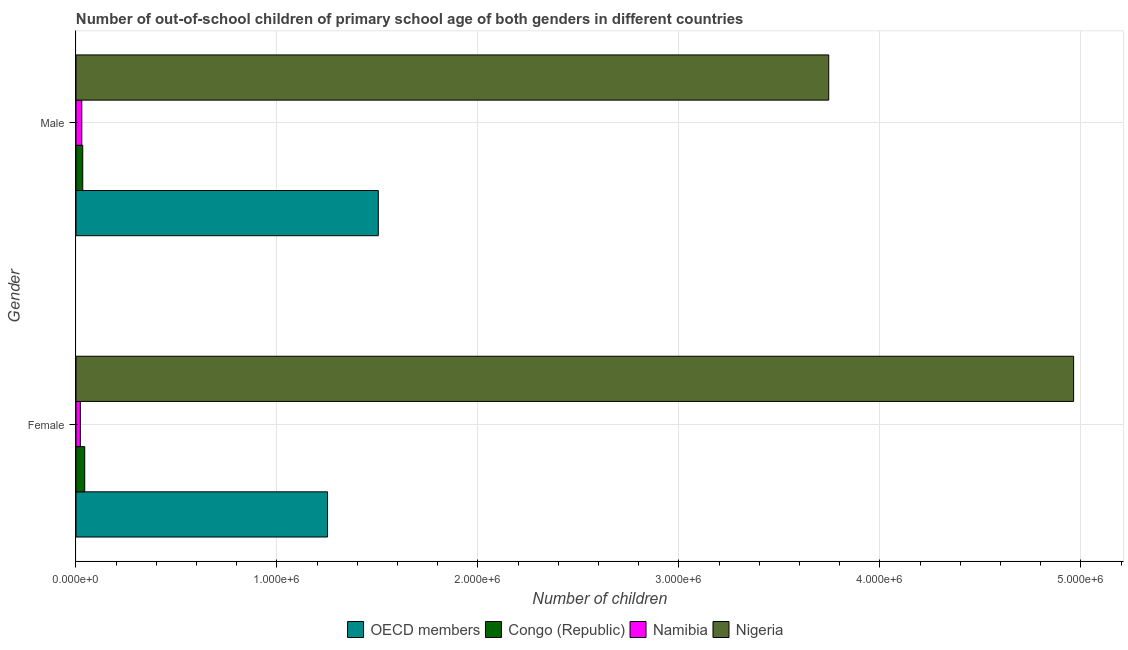Are the number of bars per tick equal to the number of legend labels?
Offer a very short reply. Yes. How many bars are there on the 2nd tick from the top?
Ensure brevity in your answer.  4. How many bars are there on the 2nd tick from the bottom?
Give a very brief answer. 4. What is the number of male out-of-school students in Namibia?
Ensure brevity in your answer.  2.89e+04. Across all countries, what is the maximum number of male out-of-school students?
Your response must be concise. 3.75e+06. Across all countries, what is the minimum number of male out-of-school students?
Provide a short and direct response. 2.89e+04. In which country was the number of female out-of-school students maximum?
Offer a very short reply. Nigeria. In which country was the number of male out-of-school students minimum?
Your response must be concise. Namibia. What is the total number of male out-of-school students in the graph?
Ensure brevity in your answer.  5.31e+06. What is the difference between the number of male out-of-school students in OECD members and that in Namibia?
Your response must be concise. 1.48e+06. What is the difference between the number of female out-of-school students in Nigeria and the number of male out-of-school students in Congo (Republic)?
Provide a succinct answer. 4.93e+06. What is the average number of female out-of-school students per country?
Your response must be concise. 1.57e+06. What is the difference between the number of male out-of-school students and number of female out-of-school students in Congo (Republic)?
Make the answer very short. -9825. What is the ratio of the number of male out-of-school students in Congo (Republic) to that in OECD members?
Your answer should be very brief. 0.02. Is the number of male out-of-school students in Congo (Republic) less than that in OECD members?
Your response must be concise. Yes. What does the 3rd bar from the top in Male represents?
Offer a terse response. Congo (Republic). What does the 3rd bar from the bottom in Female represents?
Your response must be concise. Namibia. How many bars are there?
Provide a short and direct response. 8. How many countries are there in the graph?
Offer a terse response. 4. What is the difference between two consecutive major ticks on the X-axis?
Your response must be concise. 1.00e+06. How are the legend labels stacked?
Your answer should be very brief. Horizontal. What is the title of the graph?
Your response must be concise. Number of out-of-school children of primary school age of both genders in different countries. What is the label or title of the X-axis?
Offer a very short reply. Number of children. What is the label or title of the Y-axis?
Ensure brevity in your answer.  Gender. What is the Number of children of OECD members in Female?
Your answer should be compact. 1.25e+06. What is the Number of children of Congo (Republic) in Female?
Make the answer very short. 4.35e+04. What is the Number of children of Namibia in Female?
Your response must be concise. 2.17e+04. What is the Number of children in Nigeria in Female?
Give a very brief answer. 4.96e+06. What is the Number of children of OECD members in Male?
Provide a succinct answer. 1.50e+06. What is the Number of children in Congo (Republic) in Male?
Your response must be concise. 3.37e+04. What is the Number of children of Namibia in Male?
Provide a succinct answer. 2.89e+04. What is the Number of children of Nigeria in Male?
Give a very brief answer. 3.75e+06. Across all Gender, what is the maximum Number of children of OECD members?
Provide a short and direct response. 1.50e+06. Across all Gender, what is the maximum Number of children in Congo (Republic)?
Your response must be concise. 4.35e+04. Across all Gender, what is the maximum Number of children in Namibia?
Your answer should be compact. 2.89e+04. Across all Gender, what is the maximum Number of children in Nigeria?
Ensure brevity in your answer.  4.96e+06. Across all Gender, what is the minimum Number of children of OECD members?
Provide a short and direct response. 1.25e+06. Across all Gender, what is the minimum Number of children in Congo (Republic)?
Keep it short and to the point. 3.37e+04. Across all Gender, what is the minimum Number of children of Namibia?
Your answer should be compact. 2.17e+04. Across all Gender, what is the minimum Number of children of Nigeria?
Keep it short and to the point. 3.75e+06. What is the total Number of children in OECD members in the graph?
Your answer should be compact. 2.76e+06. What is the total Number of children in Congo (Republic) in the graph?
Ensure brevity in your answer.  7.72e+04. What is the total Number of children of Namibia in the graph?
Offer a very short reply. 5.06e+04. What is the total Number of children in Nigeria in the graph?
Keep it short and to the point. 8.71e+06. What is the difference between the Number of children in OECD members in Female and that in Male?
Keep it short and to the point. -2.52e+05. What is the difference between the Number of children in Congo (Republic) in Female and that in Male?
Make the answer very short. 9825. What is the difference between the Number of children of Namibia in Female and that in Male?
Provide a short and direct response. -7261. What is the difference between the Number of children of Nigeria in Female and that in Male?
Provide a short and direct response. 1.22e+06. What is the difference between the Number of children of OECD members in Female and the Number of children of Congo (Republic) in Male?
Make the answer very short. 1.22e+06. What is the difference between the Number of children in OECD members in Female and the Number of children in Namibia in Male?
Ensure brevity in your answer.  1.22e+06. What is the difference between the Number of children in OECD members in Female and the Number of children in Nigeria in Male?
Your answer should be compact. -2.49e+06. What is the difference between the Number of children of Congo (Republic) in Female and the Number of children of Namibia in Male?
Ensure brevity in your answer.  1.46e+04. What is the difference between the Number of children of Congo (Republic) in Female and the Number of children of Nigeria in Male?
Give a very brief answer. -3.70e+06. What is the difference between the Number of children of Namibia in Female and the Number of children of Nigeria in Male?
Offer a terse response. -3.72e+06. What is the average Number of children of OECD members per Gender?
Make the answer very short. 1.38e+06. What is the average Number of children of Congo (Republic) per Gender?
Offer a very short reply. 3.86e+04. What is the average Number of children in Namibia per Gender?
Keep it short and to the point. 2.53e+04. What is the average Number of children in Nigeria per Gender?
Your answer should be very brief. 4.35e+06. What is the difference between the Number of children of OECD members and Number of children of Congo (Republic) in Female?
Your answer should be very brief. 1.21e+06. What is the difference between the Number of children of OECD members and Number of children of Namibia in Female?
Give a very brief answer. 1.23e+06. What is the difference between the Number of children of OECD members and Number of children of Nigeria in Female?
Ensure brevity in your answer.  -3.71e+06. What is the difference between the Number of children in Congo (Republic) and Number of children in Namibia in Female?
Your response must be concise. 2.18e+04. What is the difference between the Number of children in Congo (Republic) and Number of children in Nigeria in Female?
Your answer should be compact. -4.92e+06. What is the difference between the Number of children of Namibia and Number of children of Nigeria in Female?
Ensure brevity in your answer.  -4.94e+06. What is the difference between the Number of children in OECD members and Number of children in Congo (Republic) in Male?
Provide a succinct answer. 1.47e+06. What is the difference between the Number of children in OECD members and Number of children in Namibia in Male?
Offer a terse response. 1.48e+06. What is the difference between the Number of children in OECD members and Number of children in Nigeria in Male?
Your response must be concise. -2.24e+06. What is the difference between the Number of children in Congo (Republic) and Number of children in Namibia in Male?
Offer a terse response. 4752. What is the difference between the Number of children in Congo (Republic) and Number of children in Nigeria in Male?
Keep it short and to the point. -3.71e+06. What is the difference between the Number of children in Namibia and Number of children in Nigeria in Male?
Make the answer very short. -3.72e+06. What is the ratio of the Number of children in OECD members in Female to that in Male?
Give a very brief answer. 0.83. What is the ratio of the Number of children in Congo (Republic) in Female to that in Male?
Give a very brief answer. 1.29. What is the ratio of the Number of children in Namibia in Female to that in Male?
Make the answer very short. 0.75. What is the ratio of the Number of children of Nigeria in Female to that in Male?
Offer a terse response. 1.33. What is the difference between the highest and the second highest Number of children in OECD members?
Keep it short and to the point. 2.52e+05. What is the difference between the highest and the second highest Number of children in Congo (Republic)?
Make the answer very short. 9825. What is the difference between the highest and the second highest Number of children of Namibia?
Ensure brevity in your answer.  7261. What is the difference between the highest and the second highest Number of children of Nigeria?
Offer a terse response. 1.22e+06. What is the difference between the highest and the lowest Number of children of OECD members?
Give a very brief answer. 2.52e+05. What is the difference between the highest and the lowest Number of children in Congo (Republic)?
Keep it short and to the point. 9825. What is the difference between the highest and the lowest Number of children in Namibia?
Your answer should be compact. 7261. What is the difference between the highest and the lowest Number of children of Nigeria?
Ensure brevity in your answer.  1.22e+06. 